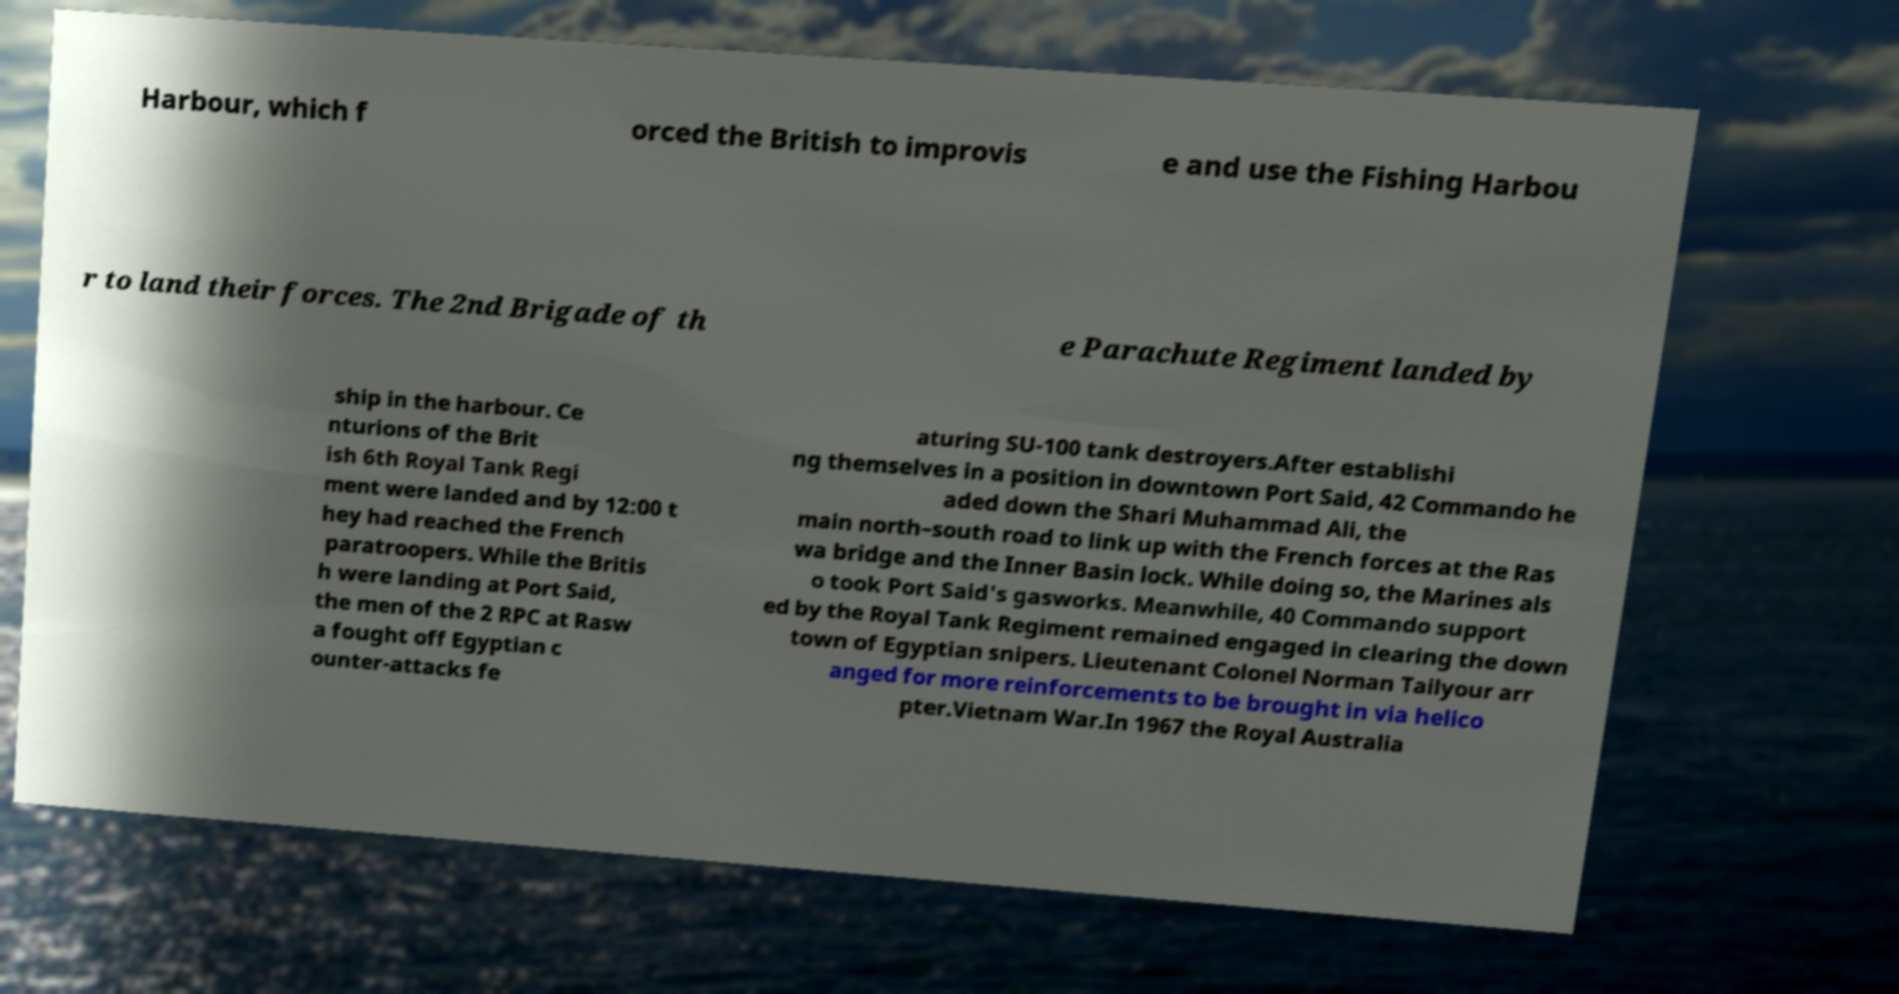Please read and relay the text visible in this image. What does it say? Harbour, which f orced the British to improvis e and use the Fishing Harbou r to land their forces. The 2nd Brigade of th e Parachute Regiment landed by ship in the harbour. Ce nturions of the Brit ish 6th Royal Tank Regi ment were landed and by 12:00 t hey had reached the French paratroopers. While the Britis h were landing at Port Said, the men of the 2 RPC at Rasw a fought off Egyptian c ounter-attacks fe aturing SU-100 tank destroyers.After establishi ng themselves in a position in downtown Port Said, 42 Commando he aded down the Shari Muhammad Ali, the main north–south road to link up with the French forces at the Ras wa bridge and the Inner Basin lock. While doing so, the Marines als o took Port Said's gasworks. Meanwhile, 40 Commando support ed by the Royal Tank Regiment remained engaged in clearing the down town of Egyptian snipers. Lieutenant Colonel Norman Tailyour arr anged for more reinforcements to be brought in via helico pter.Vietnam War.In 1967 the Royal Australia 